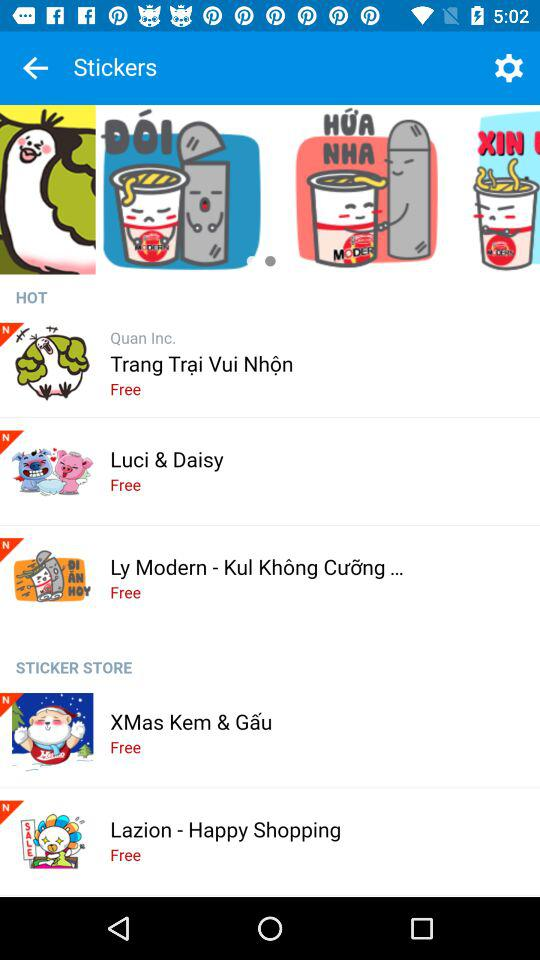How many of the stickers are free?
Answer the question using a single word or phrase. 5 